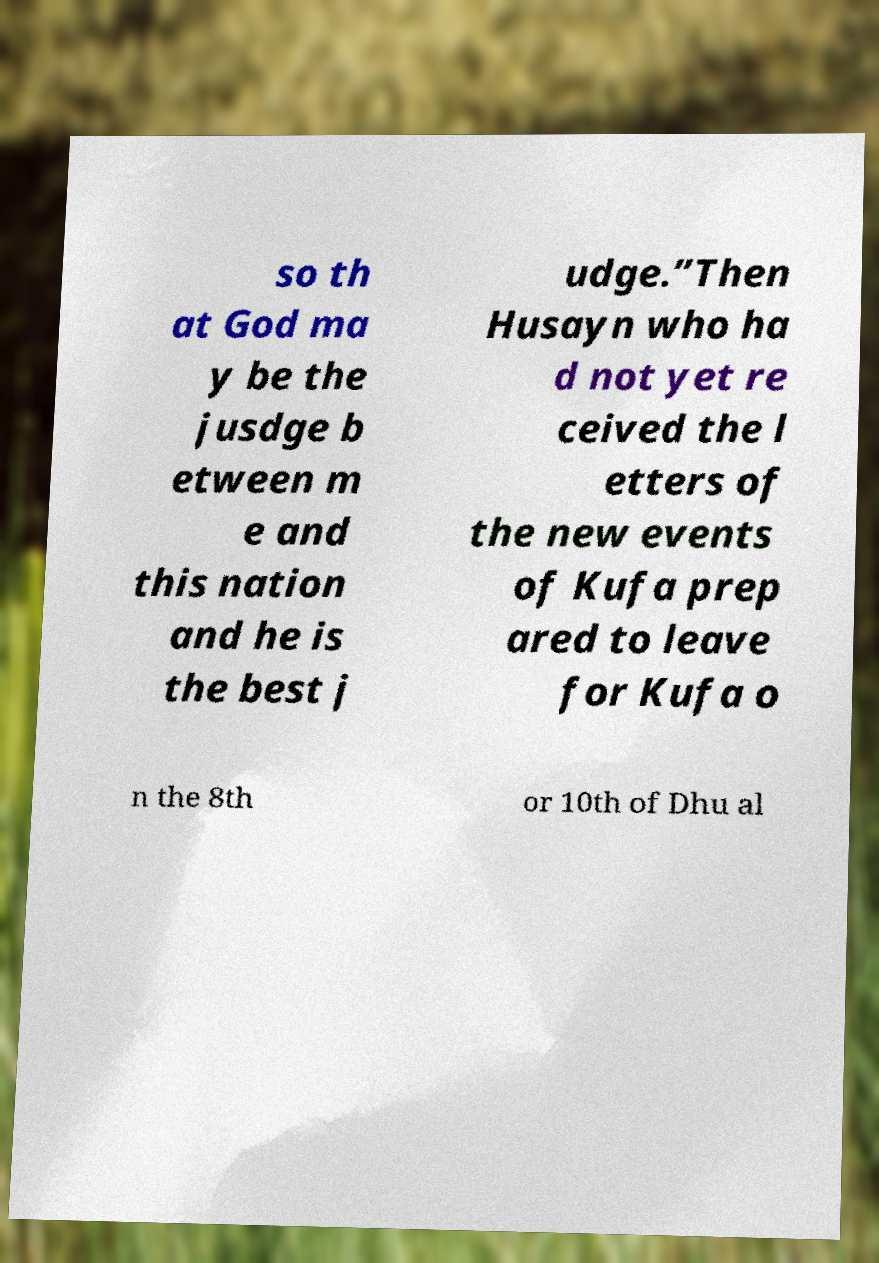For documentation purposes, I need the text within this image transcribed. Could you provide that? so th at God ma y be the jusdge b etween m e and this nation and he is the best j udge.”Then Husayn who ha d not yet re ceived the l etters of the new events of Kufa prep ared to leave for Kufa o n the 8th or 10th of Dhu al 